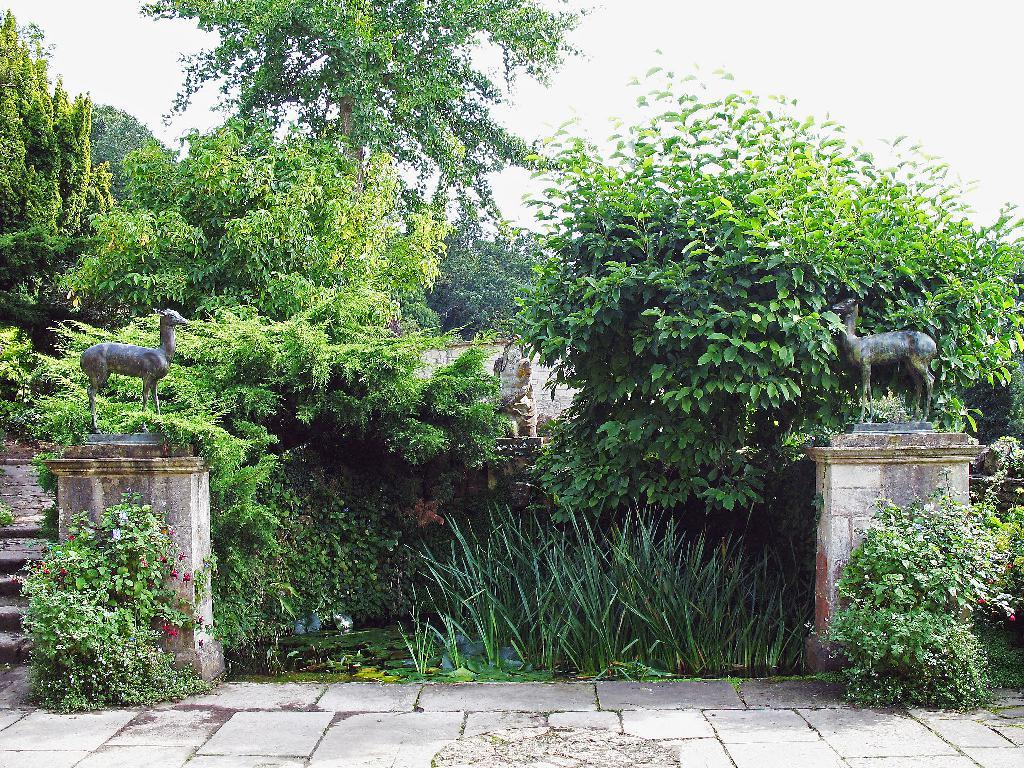What is the main feature in the center of the image? There is greenery in the center of the image. What can be seen on the right side of the image? There are sculptures on the right side of the image. What is present on the left side of the image? There are sculptures on the left side of the image. What type of corn is growing in the center of the image? There is no corn present in the image; it features greenery instead. Can you tell me which parent is depicted in the sculpture on the right side of the image? There is no parent depicted in the sculpture on the right side of the image; it is a sculpture without any human figures. 